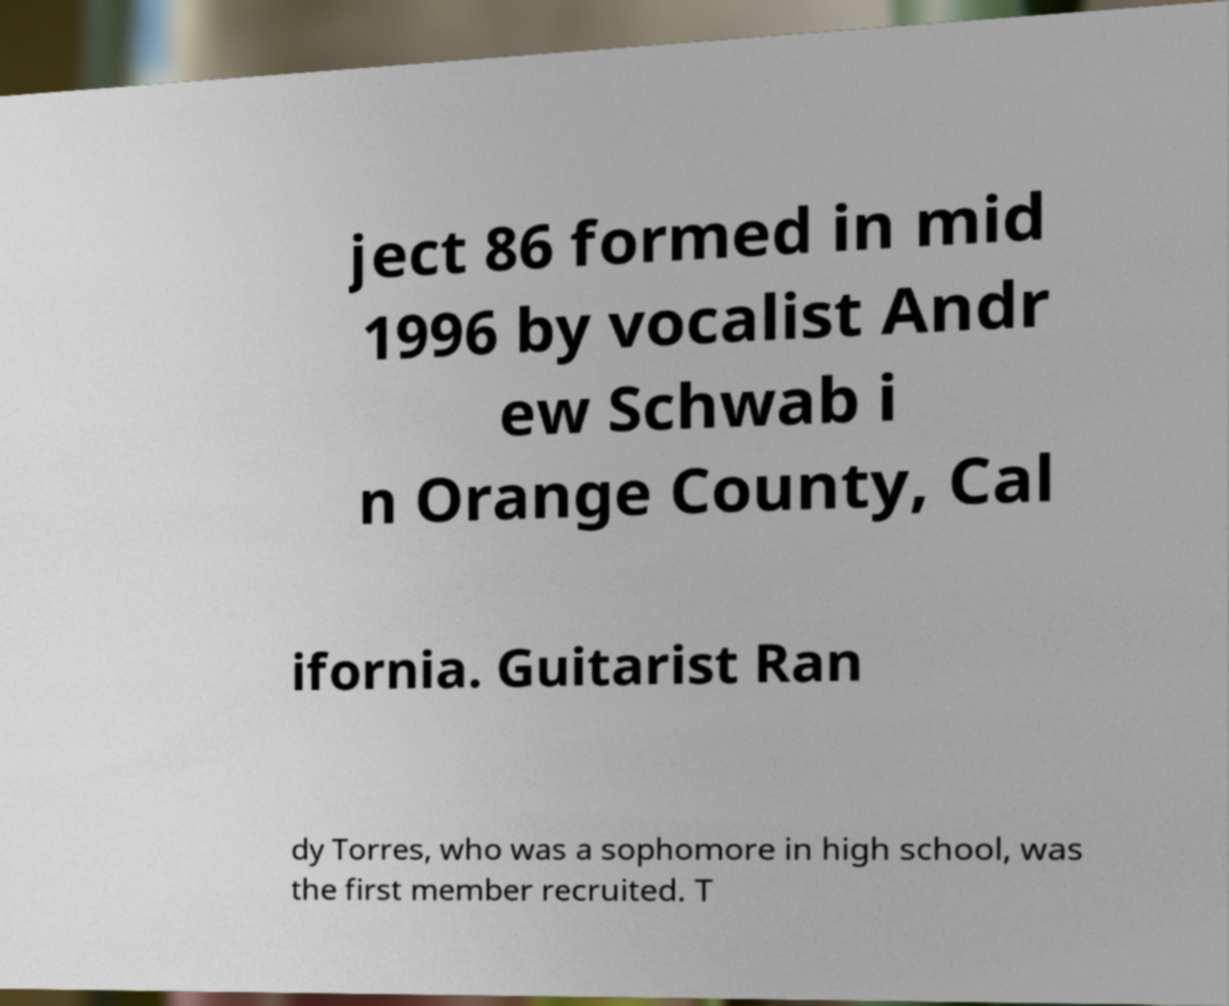For documentation purposes, I need the text within this image transcribed. Could you provide that? ject 86 formed in mid 1996 by vocalist Andr ew Schwab i n Orange County, Cal ifornia. Guitarist Ran dy Torres, who was a sophomore in high school, was the first member recruited. T 